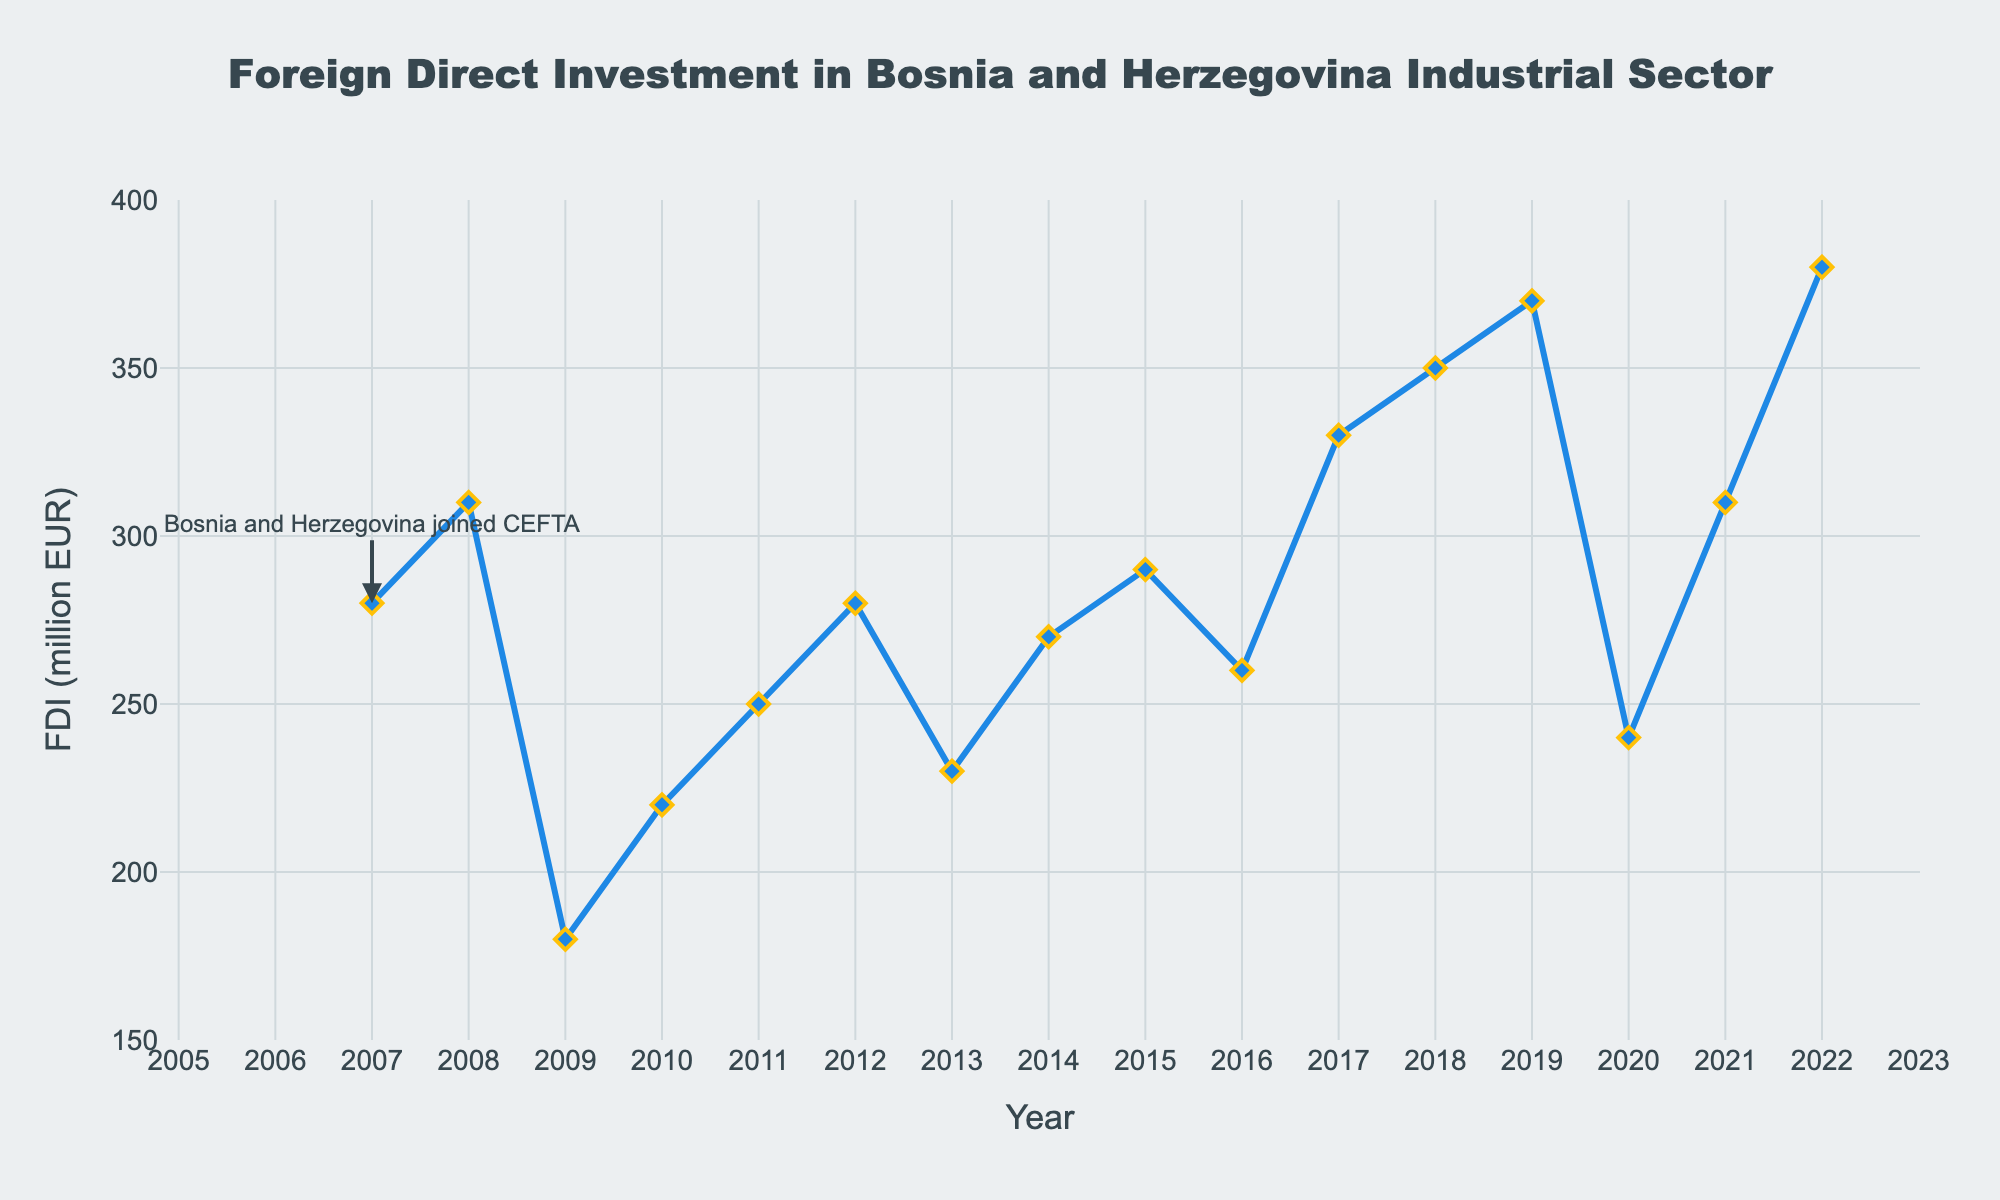What's the trend in FDI from 2007 to 2022? The foreign direct investment starts at 280 million EUR in 2007, fluctuates through the years but generally increases, peaking at 380 million EUR in 2022.
Answer: Increasing with fluctuations Which year saw the highest FDI? The year with the highest FDI is 2022, where the investment reached 380 million EUR.
Answer: 2022 What is the difference in FDI between 2019 and 2020? In 2019, the FDI is 370 million EUR, and in 2020, it is 240 million EUR. The difference is 370 - 240 = 130 million EUR.
Answer: 130 million EUR Calculate the average FDI over the period from 2007 to 2022. Sum all the FDI values from 2007 to 2022, then divide by the number of years, which is (280+310+180+220+250+280+230+270+290+260+330+350+370+240+310+380) / 16 = 4300 / 16 = 268.75 million EUR.
Answer: 268.75 million EUR Compare the FDI in 2009 and 2012. In 2009, the FDI was 180 million EUR, while in 2012, it was 280 million EUR.
Answer: 2012 had higher FDI Which year had the lowest FDI, and what was the value? The year with the lowest FDI was 2009, with 180 million EUR.
Answer: 2009, 180 million EUR What is the trend in FDI in the years following Bosnia and Herzegovina joining CEFTA? The FDI initially rose from 280 million EUR in 2007 to 310 million EUR in 2008, fell to 180 million EUR in 2009, and showed fluctuations but a general upward trend reaching 380 million EUR in 2022.
Answer: Initial fluctuation, then general increase Determine the FDI increase from 2010 to 2011. The FDI in 2010 is 220 million EUR and in 2011 is 250 million EUR. The increase is 250 - 220 = 30 million EUR.
Answer: 30 million EUR In which years did the FDI exceed 300 million EUR? The FDI exceeded 300 million EUR in the years 2008 (310), 2017 (330), 2018 (350), 2019 (370), 2021 (310), and 2022 (380).
Answer: 2008, 2017, 2018, 2019, 2021, 2022 What is the percentage change in FDI from 2016 to 2017? The FDI in 2016 is 260 million EUR and in 2017 is 330 million EUR. The percentage change is ((330 - 260) / 260) * 100 = 26.92%.
Answer: 26.92% 